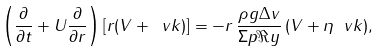Convert formula to latex. <formula><loc_0><loc_0><loc_500><loc_500>\left ( \frac { \partial } { \partial t } + U \frac { \partial } { \partial r } \right ) [ r ( V + \ v k ) ] = - r \, \frac { \rho g \Delta v } { \Sigma p \Re y } \, ( V + \eta \ v k ) ,</formula> 